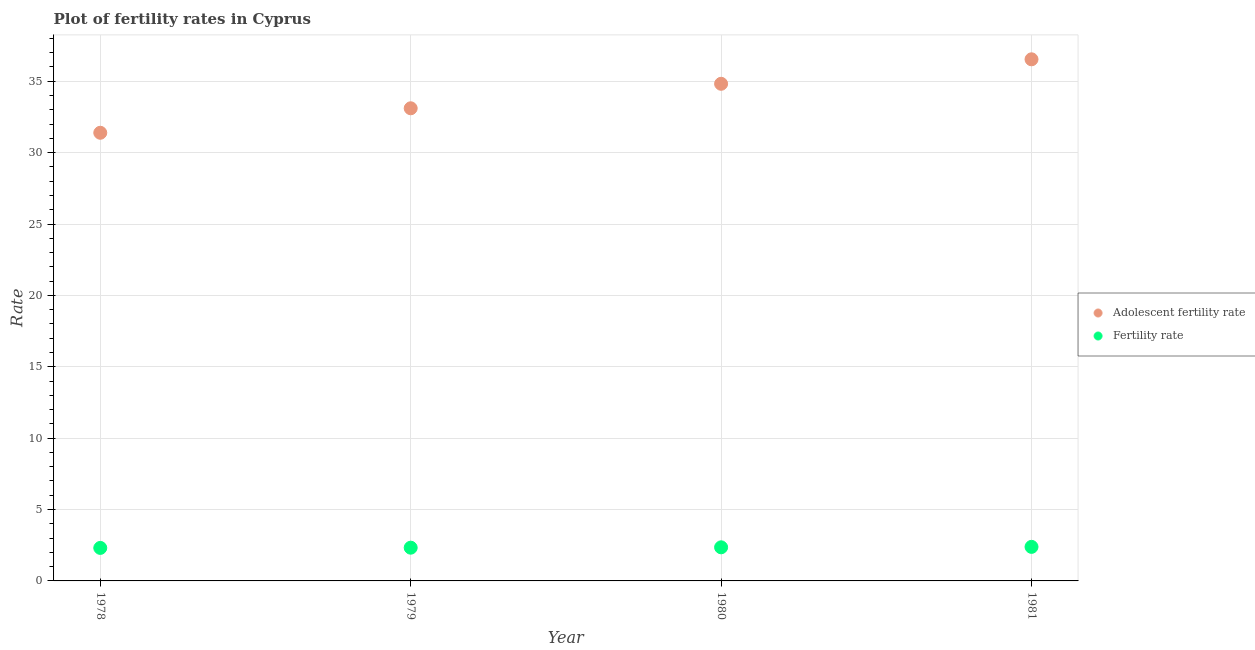How many different coloured dotlines are there?
Provide a short and direct response. 2. Is the number of dotlines equal to the number of legend labels?
Provide a succinct answer. Yes. What is the fertility rate in 1979?
Your response must be concise. 2.33. Across all years, what is the maximum fertility rate?
Your answer should be very brief. 2.38. Across all years, what is the minimum adolescent fertility rate?
Make the answer very short. 31.39. In which year was the fertility rate minimum?
Ensure brevity in your answer.  1978. What is the total fertility rate in the graph?
Keep it short and to the point. 9.38. What is the difference between the adolescent fertility rate in 1979 and that in 1980?
Your answer should be compact. -1.72. What is the difference between the adolescent fertility rate in 1979 and the fertility rate in 1980?
Your response must be concise. 30.75. What is the average adolescent fertility rate per year?
Keep it short and to the point. 33.96. In the year 1981, what is the difference between the adolescent fertility rate and fertility rate?
Keep it short and to the point. 34.15. In how many years, is the fertility rate greater than 29?
Ensure brevity in your answer.  0. What is the ratio of the fertility rate in 1978 to that in 1981?
Offer a terse response. 0.97. Is the difference between the adolescent fertility rate in 1978 and 1981 greater than the difference between the fertility rate in 1978 and 1981?
Your answer should be very brief. No. What is the difference between the highest and the second highest adolescent fertility rate?
Ensure brevity in your answer.  1.72. What is the difference between the highest and the lowest fertility rate?
Ensure brevity in your answer.  0.07. Is the sum of the fertility rate in 1978 and 1981 greater than the maximum adolescent fertility rate across all years?
Give a very brief answer. No. Does the fertility rate monotonically increase over the years?
Provide a short and direct response. Yes. Is the adolescent fertility rate strictly greater than the fertility rate over the years?
Offer a terse response. Yes. How many dotlines are there?
Make the answer very short. 2. Are the values on the major ticks of Y-axis written in scientific E-notation?
Provide a short and direct response. No. Does the graph contain any zero values?
Offer a very short reply. No. How many legend labels are there?
Your answer should be compact. 2. How are the legend labels stacked?
Make the answer very short. Vertical. What is the title of the graph?
Keep it short and to the point. Plot of fertility rates in Cyprus. Does "Private funds" appear as one of the legend labels in the graph?
Keep it short and to the point. No. What is the label or title of the X-axis?
Offer a terse response. Year. What is the label or title of the Y-axis?
Offer a very short reply. Rate. What is the Rate in Adolescent fertility rate in 1978?
Your response must be concise. 31.39. What is the Rate of Fertility rate in 1978?
Your response must be concise. 2.31. What is the Rate in Adolescent fertility rate in 1979?
Provide a short and direct response. 33.11. What is the Rate of Fertility rate in 1979?
Make the answer very short. 2.33. What is the Rate in Adolescent fertility rate in 1980?
Keep it short and to the point. 34.82. What is the Rate in Fertility rate in 1980?
Keep it short and to the point. 2.35. What is the Rate in Adolescent fertility rate in 1981?
Make the answer very short. 36.54. What is the Rate of Fertility rate in 1981?
Your answer should be compact. 2.38. Across all years, what is the maximum Rate in Adolescent fertility rate?
Provide a succinct answer. 36.54. Across all years, what is the maximum Rate of Fertility rate?
Your answer should be very brief. 2.38. Across all years, what is the minimum Rate of Adolescent fertility rate?
Offer a terse response. 31.39. Across all years, what is the minimum Rate of Fertility rate?
Offer a very short reply. 2.31. What is the total Rate in Adolescent fertility rate in the graph?
Provide a short and direct response. 135.86. What is the total Rate in Fertility rate in the graph?
Make the answer very short. 9.38. What is the difference between the Rate of Adolescent fertility rate in 1978 and that in 1979?
Your response must be concise. -1.72. What is the difference between the Rate of Fertility rate in 1978 and that in 1979?
Your answer should be compact. -0.02. What is the difference between the Rate of Adolescent fertility rate in 1978 and that in 1980?
Provide a succinct answer. -3.43. What is the difference between the Rate in Fertility rate in 1978 and that in 1980?
Offer a terse response. -0.04. What is the difference between the Rate of Adolescent fertility rate in 1978 and that in 1981?
Make the answer very short. -5.15. What is the difference between the Rate in Fertility rate in 1978 and that in 1981?
Ensure brevity in your answer.  -0.07. What is the difference between the Rate of Adolescent fertility rate in 1979 and that in 1980?
Keep it short and to the point. -1.72. What is the difference between the Rate in Fertility rate in 1979 and that in 1980?
Your response must be concise. -0.03. What is the difference between the Rate of Adolescent fertility rate in 1979 and that in 1981?
Make the answer very short. -3.43. What is the difference between the Rate of Fertility rate in 1979 and that in 1981?
Provide a short and direct response. -0.06. What is the difference between the Rate of Adolescent fertility rate in 1980 and that in 1981?
Offer a terse response. -1.72. What is the difference between the Rate in Fertility rate in 1980 and that in 1981?
Offer a very short reply. -0.03. What is the difference between the Rate in Adolescent fertility rate in 1978 and the Rate in Fertility rate in 1979?
Your response must be concise. 29.06. What is the difference between the Rate of Adolescent fertility rate in 1978 and the Rate of Fertility rate in 1980?
Your response must be concise. 29.04. What is the difference between the Rate in Adolescent fertility rate in 1978 and the Rate in Fertility rate in 1981?
Ensure brevity in your answer.  29.01. What is the difference between the Rate of Adolescent fertility rate in 1979 and the Rate of Fertility rate in 1980?
Make the answer very short. 30.75. What is the difference between the Rate of Adolescent fertility rate in 1979 and the Rate of Fertility rate in 1981?
Offer a very short reply. 30.72. What is the difference between the Rate in Adolescent fertility rate in 1980 and the Rate in Fertility rate in 1981?
Your answer should be compact. 32.44. What is the average Rate in Adolescent fertility rate per year?
Your answer should be very brief. 33.96. What is the average Rate in Fertility rate per year?
Make the answer very short. 2.34. In the year 1978, what is the difference between the Rate of Adolescent fertility rate and Rate of Fertility rate?
Provide a succinct answer. 29.08. In the year 1979, what is the difference between the Rate in Adolescent fertility rate and Rate in Fertility rate?
Your answer should be very brief. 30.78. In the year 1980, what is the difference between the Rate of Adolescent fertility rate and Rate of Fertility rate?
Ensure brevity in your answer.  32.47. In the year 1981, what is the difference between the Rate in Adolescent fertility rate and Rate in Fertility rate?
Ensure brevity in your answer.  34.15. What is the ratio of the Rate of Adolescent fertility rate in 1978 to that in 1979?
Keep it short and to the point. 0.95. What is the ratio of the Rate in Adolescent fertility rate in 1978 to that in 1980?
Provide a succinct answer. 0.9. What is the ratio of the Rate in Fertility rate in 1978 to that in 1980?
Your answer should be very brief. 0.98. What is the ratio of the Rate of Adolescent fertility rate in 1978 to that in 1981?
Make the answer very short. 0.86. What is the ratio of the Rate of Fertility rate in 1978 to that in 1981?
Provide a succinct answer. 0.97. What is the ratio of the Rate of Adolescent fertility rate in 1979 to that in 1980?
Offer a very short reply. 0.95. What is the ratio of the Rate of Adolescent fertility rate in 1979 to that in 1981?
Make the answer very short. 0.91. What is the ratio of the Rate in Fertility rate in 1979 to that in 1981?
Provide a short and direct response. 0.98. What is the ratio of the Rate of Adolescent fertility rate in 1980 to that in 1981?
Your response must be concise. 0.95. What is the ratio of the Rate in Fertility rate in 1980 to that in 1981?
Offer a terse response. 0.99. What is the difference between the highest and the second highest Rate of Adolescent fertility rate?
Make the answer very short. 1.72. What is the difference between the highest and the second highest Rate in Fertility rate?
Provide a succinct answer. 0.03. What is the difference between the highest and the lowest Rate of Adolescent fertility rate?
Keep it short and to the point. 5.15. What is the difference between the highest and the lowest Rate in Fertility rate?
Keep it short and to the point. 0.07. 